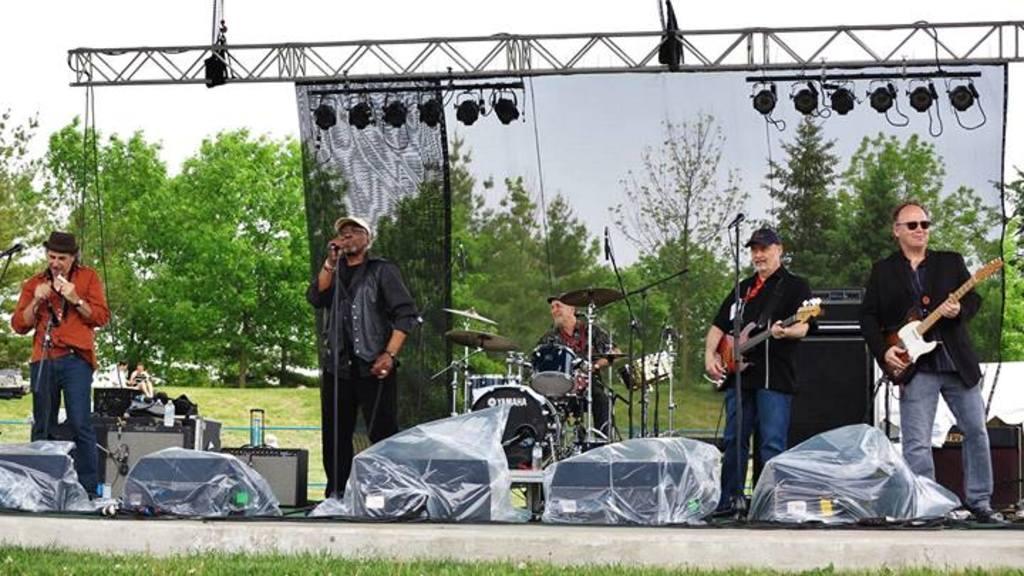Please provide a concise description of this image. There are five men on the stage performing a show. Two of them holding guitars,two of them holding mike's, one person behind the drums. One person wearing a black jacket and white cap. Another person wearing a orange shirt and blue jeans with the black hat. These two wearing a black. One person wearing a cap and one person wearing goggles. In the background, there are group of trees and also blue sky and some lights are attached to the stage and they were two persons sitting behind the stage. 